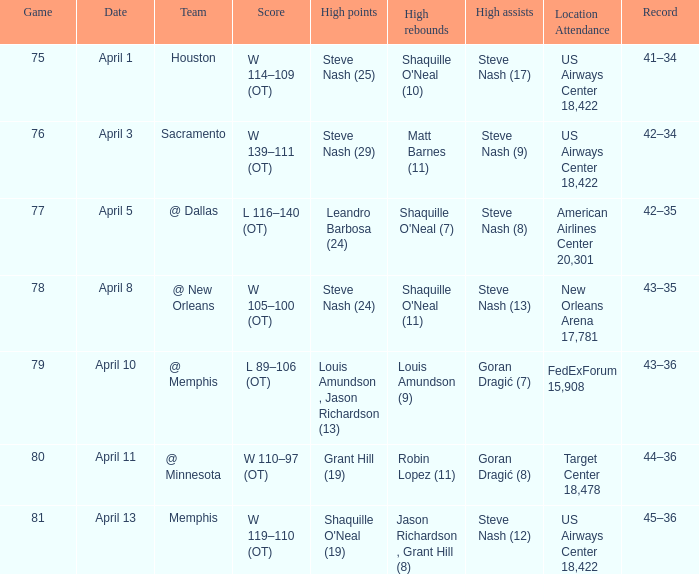Steve Nash (24) got high points for how many teams? 1.0. 